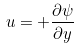<formula> <loc_0><loc_0><loc_500><loc_500>u = + \frac { \partial \psi } { \partial y }</formula> 